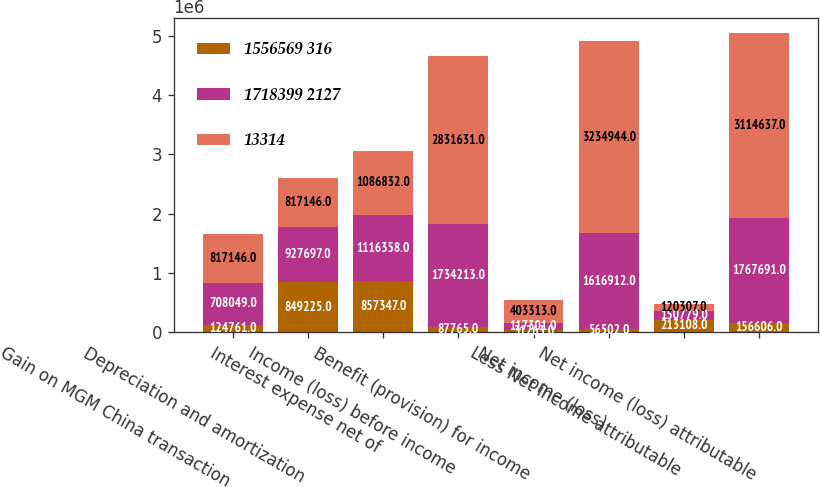Convert chart to OTSL. <chart><loc_0><loc_0><loc_500><loc_500><stacked_bar_chart><ecel><fcel>Gain on MGM China transaction<fcel>Depreciation and amortization<fcel>Interest expense net of<fcel>Income (loss) before income<fcel>Benefit (provision) for income<fcel>Net income (loss)<fcel>Less Net income attributable<fcel>Net income (loss) attributable<nl><fcel>1556569 316<fcel>124761<fcel>849225<fcel>857347<fcel>87765<fcel>31263<fcel>56502<fcel>213108<fcel>156606<nl><fcel>1718399 2127<fcel>708049<fcel>927697<fcel>1.11636e+06<fcel>1.73421e+06<fcel>117301<fcel>1.61691e+06<fcel>150779<fcel>1.76769e+06<nl><fcel>13314<fcel>817146<fcel>817146<fcel>1.08683e+06<fcel>2.83163e+06<fcel>403313<fcel>3.23494e+06<fcel>120307<fcel>3.11464e+06<nl></chart> 